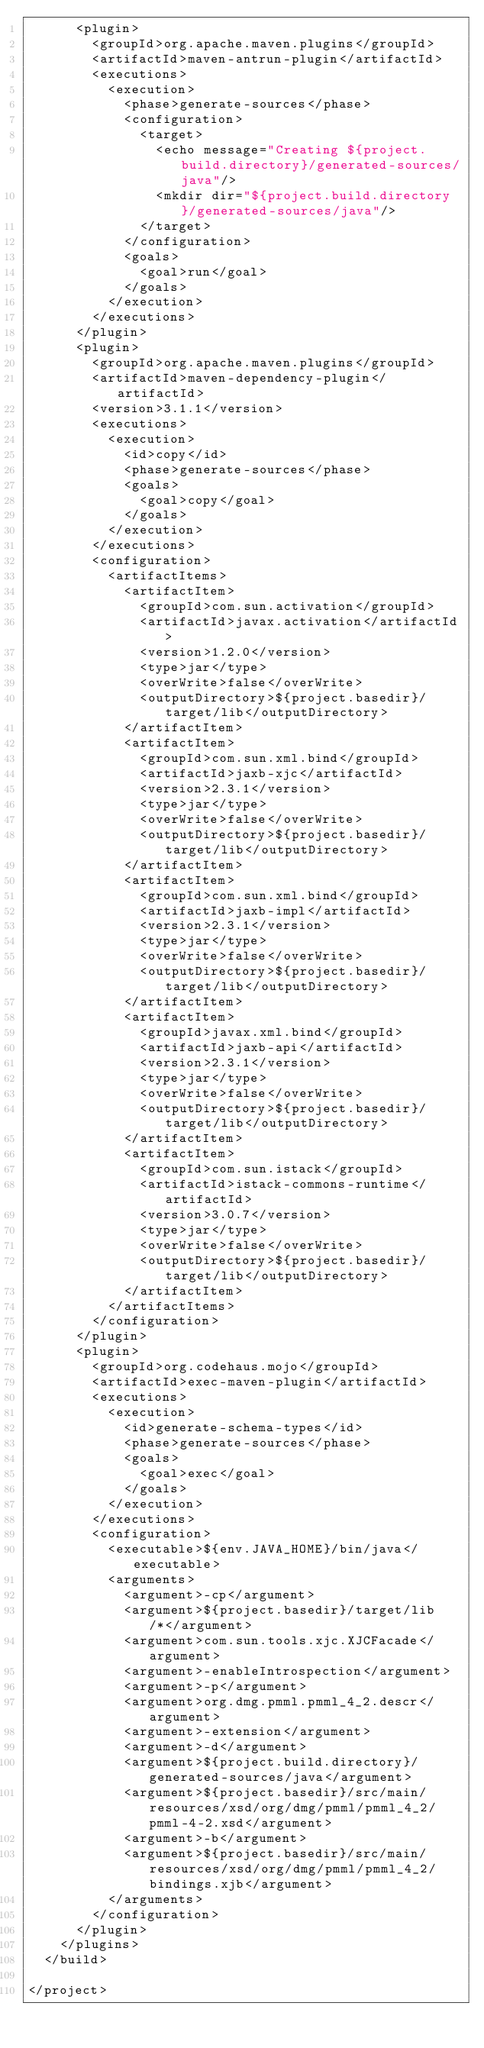<code> <loc_0><loc_0><loc_500><loc_500><_XML_>      <plugin>
        <groupId>org.apache.maven.plugins</groupId>
        <artifactId>maven-antrun-plugin</artifactId>
        <executions>
          <execution>
            <phase>generate-sources</phase>
            <configuration>
              <target>
                <echo message="Creating ${project.build.directory}/generated-sources/java"/>
                <mkdir dir="${project.build.directory}/generated-sources/java"/>
              </target>
            </configuration>
            <goals>
              <goal>run</goal>
            </goals>
          </execution>
        </executions>
      </plugin>
      <plugin>
        <groupId>org.apache.maven.plugins</groupId>
        <artifactId>maven-dependency-plugin</artifactId>
        <version>3.1.1</version>
        <executions>
          <execution>
            <id>copy</id>
            <phase>generate-sources</phase>
            <goals>
              <goal>copy</goal>
            </goals>
          </execution>
        </executions>
        <configuration>
          <artifactItems>
            <artifactItem>
              <groupId>com.sun.activation</groupId>
              <artifactId>javax.activation</artifactId>
              <version>1.2.0</version>
              <type>jar</type>
              <overWrite>false</overWrite>
              <outputDirectory>${project.basedir}/target/lib</outputDirectory>
            </artifactItem>
            <artifactItem>
              <groupId>com.sun.xml.bind</groupId>
              <artifactId>jaxb-xjc</artifactId>
              <version>2.3.1</version>
              <type>jar</type>
              <overWrite>false</overWrite>
              <outputDirectory>${project.basedir}/target/lib</outputDirectory>
            </artifactItem>
            <artifactItem>
              <groupId>com.sun.xml.bind</groupId>
              <artifactId>jaxb-impl</artifactId>
              <version>2.3.1</version>
              <type>jar</type>
              <overWrite>false</overWrite>
              <outputDirectory>${project.basedir}/target/lib</outputDirectory>
            </artifactItem>
            <artifactItem>
              <groupId>javax.xml.bind</groupId>
              <artifactId>jaxb-api</artifactId>
              <version>2.3.1</version>
              <type>jar</type>
              <overWrite>false</overWrite>
              <outputDirectory>${project.basedir}/target/lib</outputDirectory>
            </artifactItem>
            <artifactItem>
              <groupId>com.sun.istack</groupId>
              <artifactId>istack-commons-runtime</artifactId>
              <version>3.0.7</version>
              <type>jar</type>
              <overWrite>false</overWrite>
              <outputDirectory>${project.basedir}/target/lib</outputDirectory>
            </artifactItem>
          </artifactItems>
        </configuration>
      </plugin>
      <plugin>
        <groupId>org.codehaus.mojo</groupId>
        <artifactId>exec-maven-plugin</artifactId>
        <executions>
          <execution>
            <id>generate-schema-types</id>
            <phase>generate-sources</phase>
            <goals>
              <goal>exec</goal>
            </goals>
          </execution>
        </executions>
        <configuration>
          <executable>${env.JAVA_HOME}/bin/java</executable>
          <arguments>
            <argument>-cp</argument>
            <argument>${project.basedir}/target/lib/*</argument>
            <argument>com.sun.tools.xjc.XJCFacade</argument>
            <argument>-enableIntrospection</argument>
            <argument>-p</argument>
            <argument>org.dmg.pmml.pmml_4_2.descr</argument>
            <argument>-extension</argument>
            <argument>-d</argument>
            <argument>${project.build.directory}/generated-sources/java</argument>
            <argument>${project.basedir}/src/main/resources/xsd/org/dmg/pmml/pmml_4_2/pmml-4-2.xsd</argument>
            <argument>-b</argument>
            <argument>${project.basedir}/src/main/resources/xsd/org/dmg/pmml/pmml_4_2/bindings.xjb</argument>
          </arguments>
        </configuration>
      </plugin>
    </plugins>
  </build>

</project>
</code> 